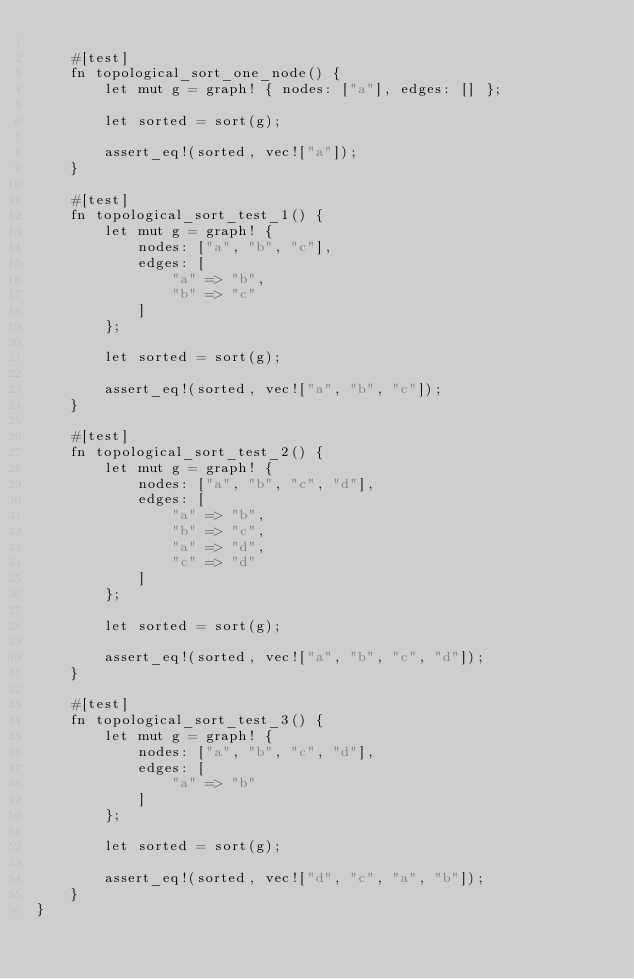Convert code to text. <code><loc_0><loc_0><loc_500><loc_500><_Rust_>
    #[test]
    fn topological_sort_one_node() {
        let mut g = graph! { nodes: ["a"], edges: [] };

        let sorted = sort(g);

        assert_eq!(sorted, vec!["a"]);
    }

    #[test]
    fn topological_sort_test_1() {
        let mut g = graph! {
            nodes: ["a", "b", "c"],
            edges: [
                "a" => "b",
                "b" => "c"
            ]
        };

        let sorted = sort(g);

        assert_eq!(sorted, vec!["a", "b", "c"]);
    }

    #[test]
    fn topological_sort_test_2() {
        let mut g = graph! {
            nodes: ["a", "b", "c", "d"],
            edges: [
                "a" => "b",
                "b" => "c",
                "a" => "d",
                "c" => "d"
            ]
        };

        let sorted = sort(g);

        assert_eq!(sorted, vec!["a", "b", "c", "d"]);
    }

    #[test]
    fn topological_sort_test_3() {
        let mut g = graph! {
            nodes: ["a", "b", "c", "d"],
            edges: [
                "a" => "b"
            ]
        };

        let sorted = sort(g);

        assert_eq!(sorted, vec!["d", "c", "a", "b"]);
    }
}
</code> 